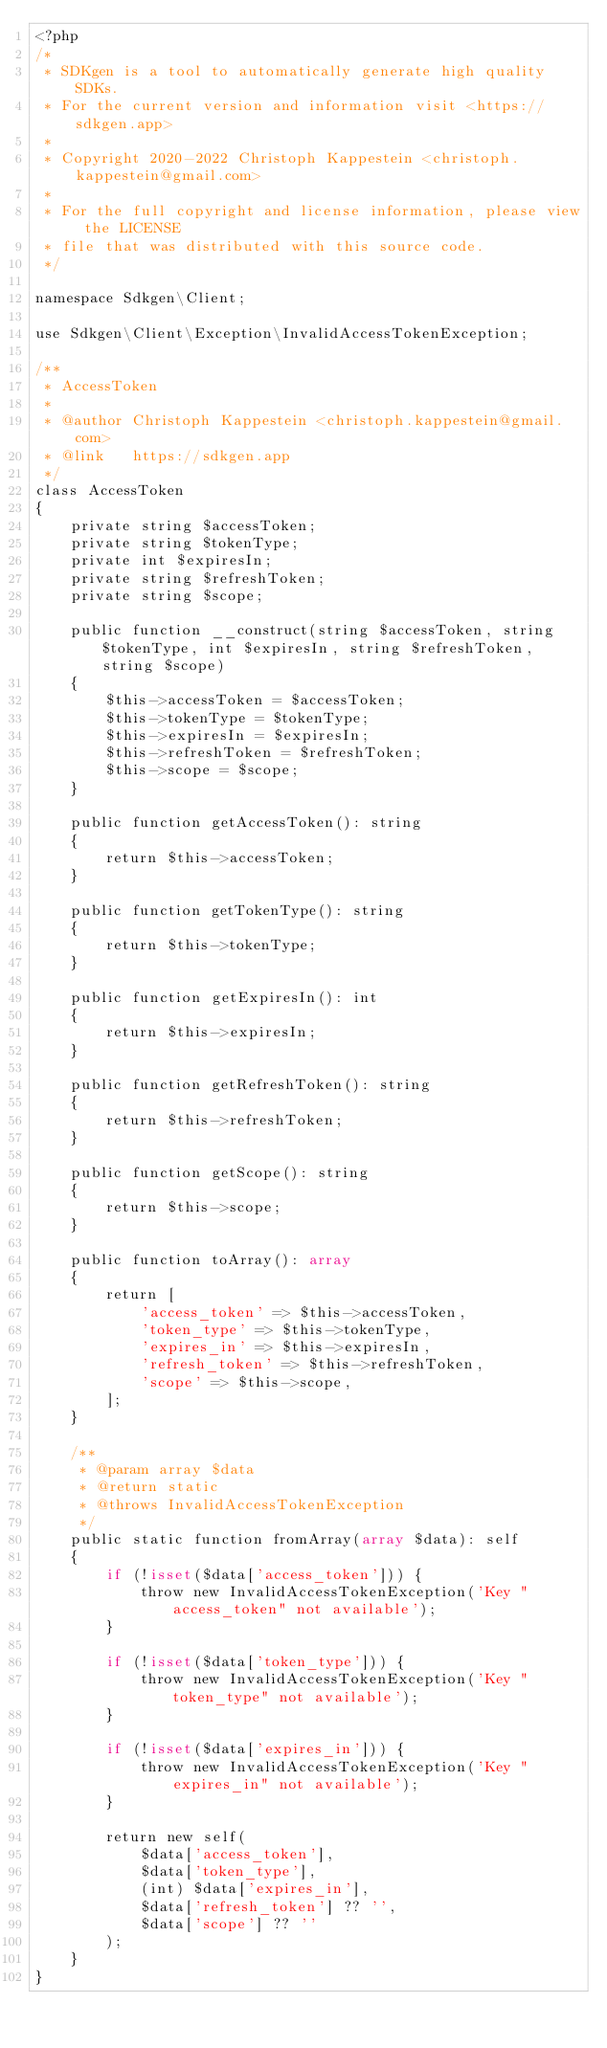<code> <loc_0><loc_0><loc_500><loc_500><_PHP_><?php
/*
 * SDKgen is a tool to automatically generate high quality SDKs.
 * For the current version and information visit <https://sdkgen.app>
 *
 * Copyright 2020-2022 Christoph Kappestein <christoph.kappestein@gmail.com>
 *
 * For the full copyright and license information, please view the LICENSE
 * file that was distributed with this source code.
 */

namespace Sdkgen\Client;

use Sdkgen\Client\Exception\InvalidAccessTokenException;

/**
 * AccessToken
 *
 * @author Christoph Kappestein <christoph.kappestein@gmail.com>
 * @link   https://sdkgen.app
 */
class AccessToken
{
    private string $accessToken;
    private string $tokenType;
    private int $expiresIn;
    private string $refreshToken;
    private string $scope;

    public function __construct(string $accessToken, string $tokenType, int $expiresIn, string $refreshToken, string $scope)
    {
        $this->accessToken = $accessToken;
        $this->tokenType = $tokenType;
        $this->expiresIn = $expiresIn;
        $this->refreshToken = $refreshToken;
        $this->scope = $scope;
    }

    public function getAccessToken(): string
    {
        return $this->accessToken;
    }

    public function getTokenType(): string
    {
        return $this->tokenType;
    }

    public function getExpiresIn(): int
    {
        return $this->expiresIn;
    }

    public function getRefreshToken(): string
    {
        return $this->refreshToken;
    }

    public function getScope(): string
    {
        return $this->scope;
    }

    public function toArray(): array
    {
        return [
            'access_token' => $this->accessToken,
            'token_type' => $this->tokenType,
            'expires_in' => $this->expiresIn,
            'refresh_token' => $this->refreshToken,
            'scope' => $this->scope,
        ];
    }

    /**
     * @param array $data
     * @return static
     * @throws InvalidAccessTokenException
     */
    public static function fromArray(array $data): self
    {
        if (!isset($data['access_token'])) {
            throw new InvalidAccessTokenException('Key "access_token" not available');
        }

        if (!isset($data['token_type'])) {
            throw new InvalidAccessTokenException('Key "token_type" not available');
        }

        if (!isset($data['expires_in'])) {
            throw new InvalidAccessTokenException('Key "expires_in" not available');
        }

        return new self(
            $data['access_token'],
            $data['token_type'],
            (int) $data['expires_in'],
            $data['refresh_token'] ?? '',
            $data['scope'] ?? ''
        );
    }
}
</code> 